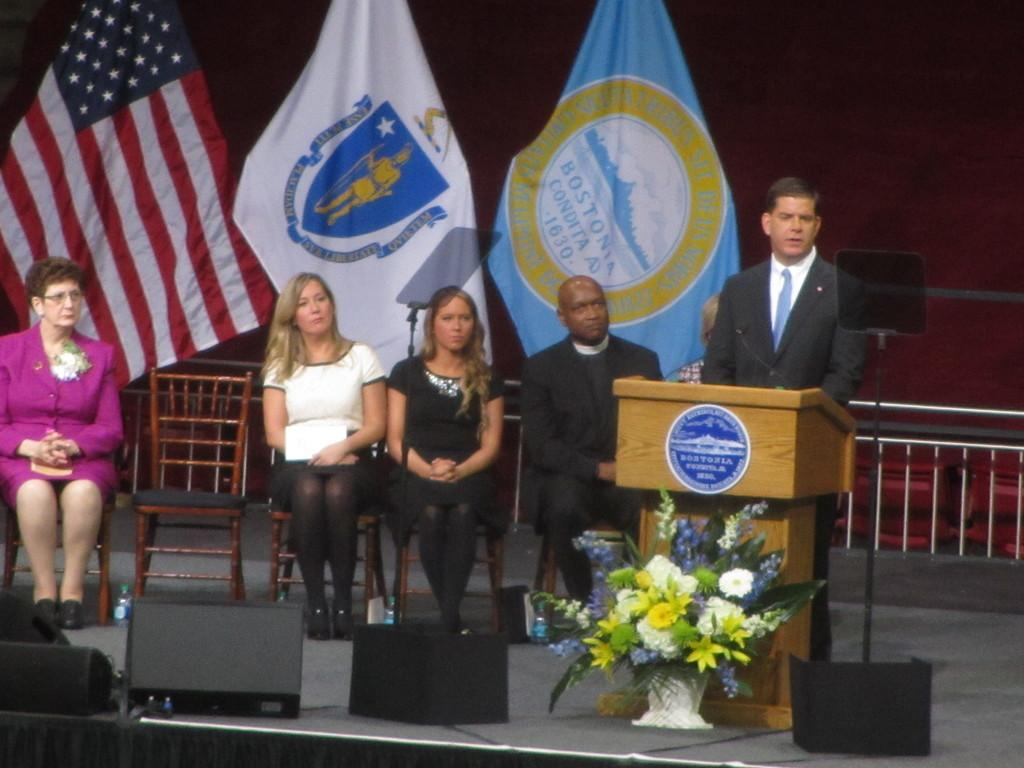How many people are sitting in the image? There are five people sitting on chairs in the image. What is the person in the front doing? One person is standing and giving a speech. What can be seen in the background of the image? There are three flags and a wall in the background of the image. What type of decoration is on the floor in the image? There are flowers on the floor in the image. What is the plot of the story being told by the person giving a speech in the image? There is no story being told in the image, as it is a still photograph. How big are the flowers on the floor in the image? The size of the flowers cannot be determined from the image alone, as there is no reference for scale. 